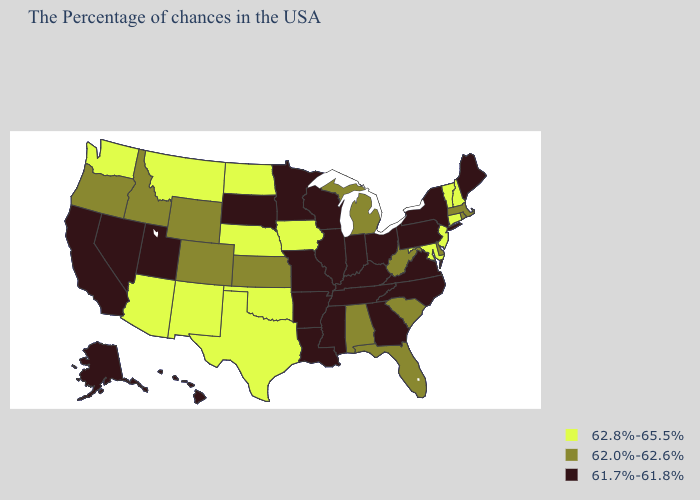Name the states that have a value in the range 62.0%-62.6%?
Quick response, please. Massachusetts, Rhode Island, Delaware, South Carolina, West Virginia, Florida, Michigan, Alabama, Kansas, Wyoming, Colorado, Idaho, Oregon. What is the value of Louisiana?
Quick response, please. 61.7%-61.8%. What is the value of Louisiana?
Answer briefly. 61.7%-61.8%. Which states hav the highest value in the MidWest?
Write a very short answer. Iowa, Nebraska, North Dakota. Which states hav the highest value in the West?
Short answer required. New Mexico, Montana, Arizona, Washington. Does the first symbol in the legend represent the smallest category?
Answer briefly. No. What is the highest value in the USA?
Concise answer only. 62.8%-65.5%. Name the states that have a value in the range 62.8%-65.5%?
Write a very short answer. New Hampshire, Vermont, Connecticut, New Jersey, Maryland, Iowa, Nebraska, Oklahoma, Texas, North Dakota, New Mexico, Montana, Arizona, Washington. How many symbols are there in the legend?
Be succinct. 3. Does the map have missing data?
Answer briefly. No. Which states have the lowest value in the MidWest?
Answer briefly. Ohio, Indiana, Wisconsin, Illinois, Missouri, Minnesota, South Dakota. What is the value of California?
Keep it brief. 61.7%-61.8%. What is the value of Colorado?
Quick response, please. 62.0%-62.6%. Is the legend a continuous bar?
Keep it brief. No. Among the states that border South Carolina , which have the lowest value?
Quick response, please. North Carolina, Georgia. 